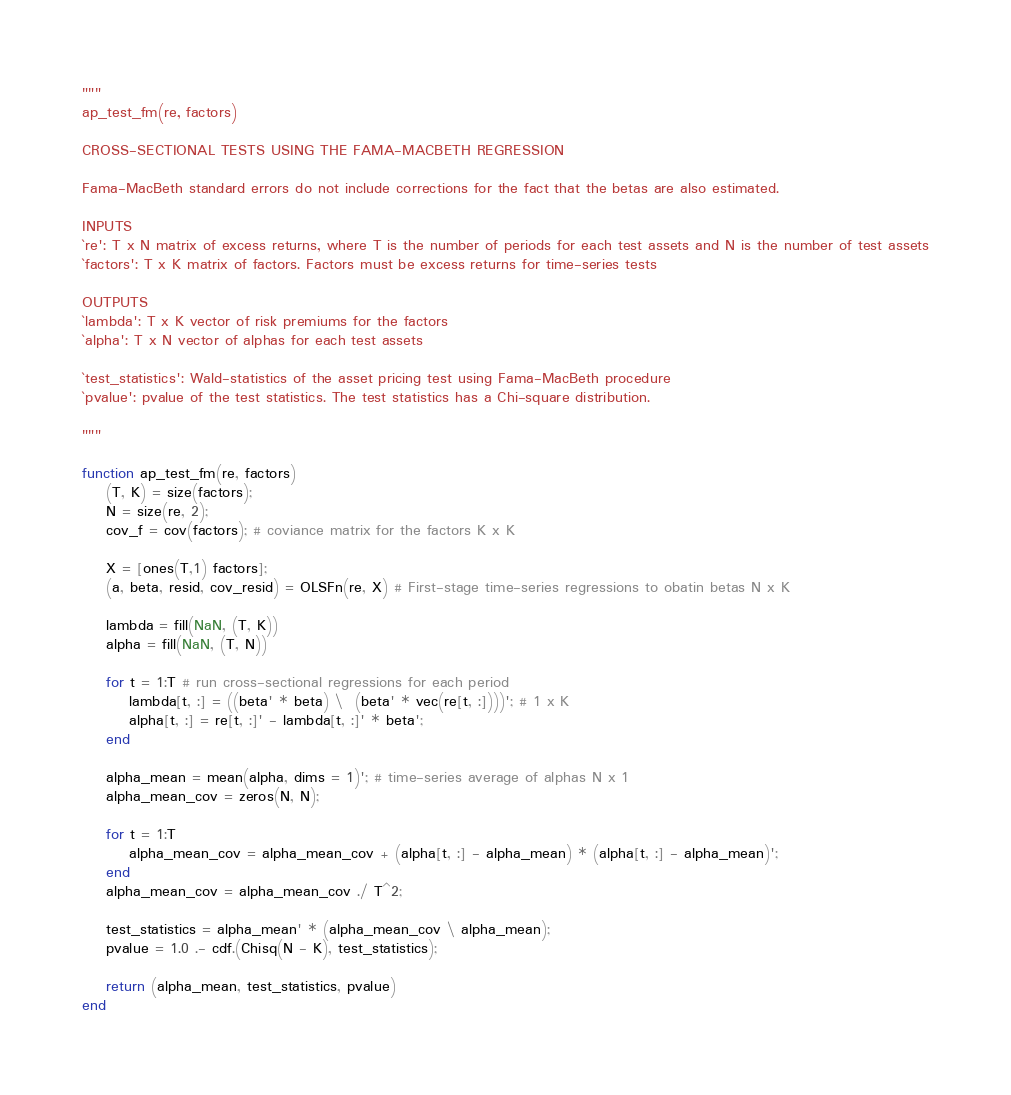<code> <loc_0><loc_0><loc_500><loc_500><_Julia_>"""
ap_test_fm(re, factors)

CROSS-SECTIONAL TESTS USING THE FAMA-MACBETH REGRESSION

Fama-MacBeth standard errors do not include corrections for the fact that the betas are also estimated.

INPUTS
`re': T x N matrix of excess returns, where T is the number of periods for each test assets and N is the number of test assets
`factors': T x K matrix of factors. Factors must be excess returns for time-series tests

OUTPUTS
`lambda': T x K vector of risk premiums for the factors
`alpha': T x N vector of alphas for each test assets

`test_statistics': Wald-statistics of the asset pricing test using Fama-MacBeth procedure
`pvalue': pvalue of the test statistics. The test statistics has a Chi-square distribution.

"""

function ap_test_fm(re, factors)
    (T, K) = size(factors);
    N = size(re, 2);
    cov_f = cov(factors); # coviance matrix for the factors K x K

    X = [ones(T,1) factors];
    (a, beta, resid, cov_resid) = OLSFn(re, X) # First-stage time-series regressions to obatin betas N x K

    lambda = fill(NaN, (T, K))
    alpha = fill(NaN, (T, N))
    
    for t = 1:T # run cross-sectional regressions for each period
        lambda[t, :] = ((beta' * beta) \  (beta' * vec(re[t, :])))'; # 1 x K
        alpha[t, :] = re[t, :]' - lambda[t, :]' * beta';
    end

    alpha_mean = mean(alpha, dims = 1)'; # time-series average of alphas N x 1
    alpha_mean_cov = zeros(N, N);
        
    for t = 1:T
        alpha_mean_cov = alpha_mean_cov + (alpha[t, :] - alpha_mean) * (alpha[t, :] - alpha_mean)';
    end
    alpha_mean_cov = alpha_mean_cov ./ T^2;
    
    test_statistics = alpha_mean' * (alpha_mean_cov \ alpha_mean);
    pvalue = 1.0 .- cdf.(Chisq(N - K), test_statistics);

    return (alpha_mean, test_statistics, pvalue)
end
</code> 